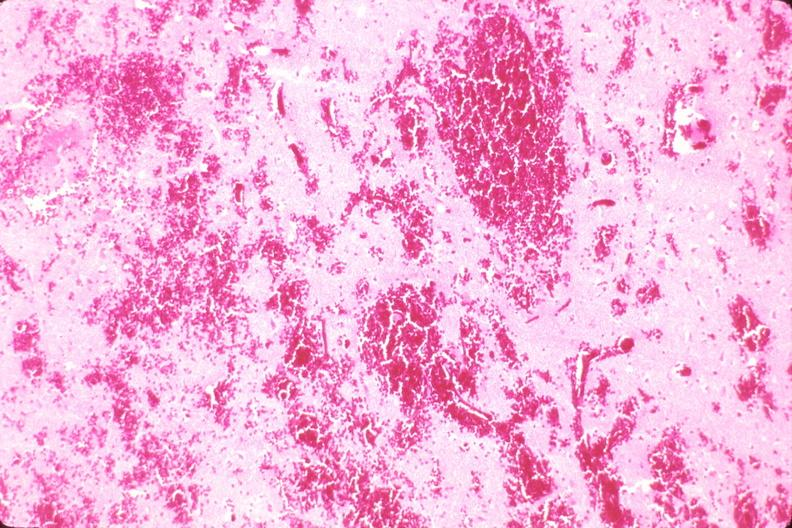where is this?
Answer the question using a single word or phrase. Nervous 